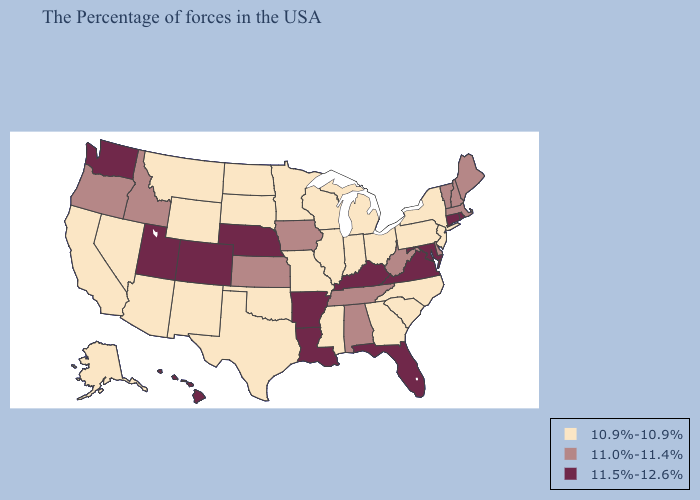What is the value of Michigan?
Give a very brief answer. 10.9%-10.9%. What is the lowest value in the Northeast?
Give a very brief answer. 10.9%-10.9%. Name the states that have a value in the range 11.0%-11.4%?
Give a very brief answer. Maine, Massachusetts, New Hampshire, Vermont, Delaware, West Virginia, Alabama, Tennessee, Iowa, Kansas, Idaho, Oregon. Name the states that have a value in the range 11.5%-12.6%?
Short answer required. Rhode Island, Connecticut, Maryland, Virginia, Florida, Kentucky, Louisiana, Arkansas, Nebraska, Colorado, Utah, Washington, Hawaii. Does California have the lowest value in the USA?
Keep it brief. Yes. Does the first symbol in the legend represent the smallest category?
Write a very short answer. Yes. Does South Dakota have a higher value than North Carolina?
Be succinct. No. Does Florida have the highest value in the USA?
Keep it brief. Yes. What is the lowest value in the USA?
Quick response, please. 10.9%-10.9%. Name the states that have a value in the range 11.5%-12.6%?
Answer briefly. Rhode Island, Connecticut, Maryland, Virginia, Florida, Kentucky, Louisiana, Arkansas, Nebraska, Colorado, Utah, Washington, Hawaii. Which states hav the highest value in the West?
Keep it brief. Colorado, Utah, Washington, Hawaii. What is the highest value in the MidWest ?
Short answer required. 11.5%-12.6%. Name the states that have a value in the range 10.9%-10.9%?
Answer briefly. New York, New Jersey, Pennsylvania, North Carolina, South Carolina, Ohio, Georgia, Michigan, Indiana, Wisconsin, Illinois, Mississippi, Missouri, Minnesota, Oklahoma, Texas, South Dakota, North Dakota, Wyoming, New Mexico, Montana, Arizona, Nevada, California, Alaska. What is the highest value in the USA?
Keep it brief. 11.5%-12.6%. 